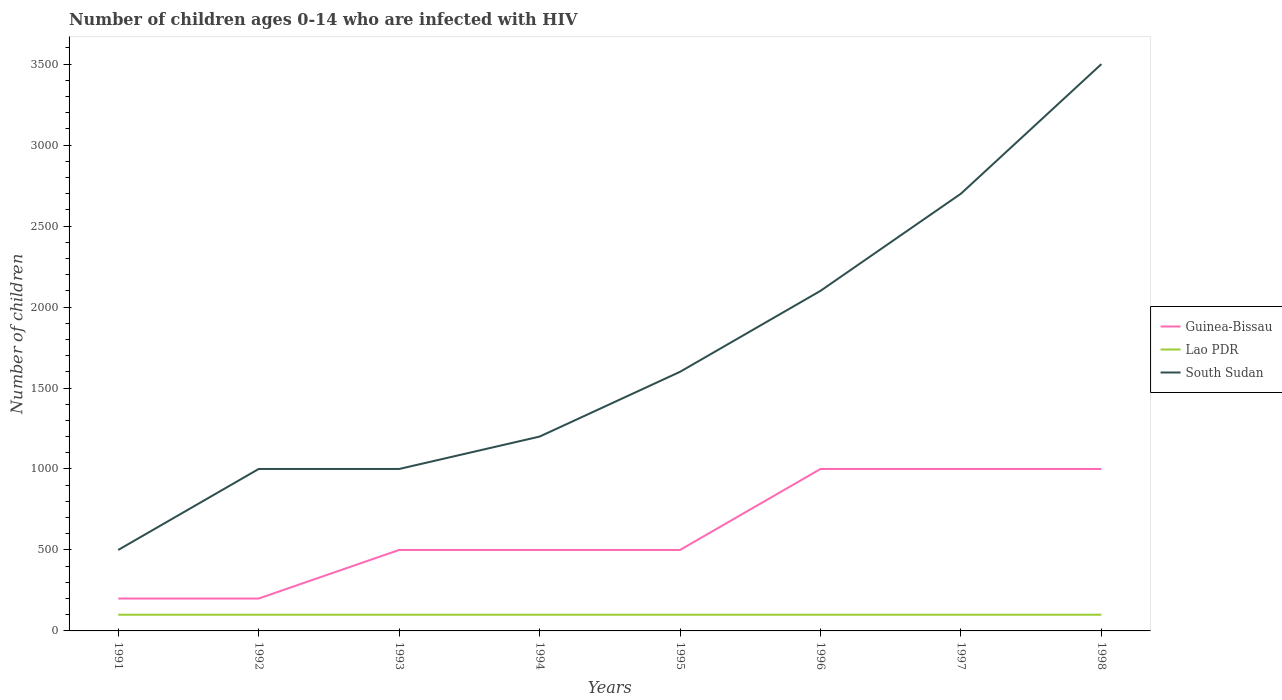How many different coloured lines are there?
Make the answer very short. 3. Is the number of lines equal to the number of legend labels?
Keep it short and to the point. Yes. Across all years, what is the maximum number of HIV infected children in Lao PDR?
Ensure brevity in your answer.  100. What is the difference between the highest and the second highest number of HIV infected children in Lao PDR?
Give a very brief answer. 0. Is the number of HIV infected children in Guinea-Bissau strictly greater than the number of HIV infected children in South Sudan over the years?
Your answer should be compact. Yes. How many years are there in the graph?
Give a very brief answer. 8. What is the difference between two consecutive major ticks on the Y-axis?
Give a very brief answer. 500. Does the graph contain any zero values?
Your answer should be very brief. No. Does the graph contain grids?
Your answer should be very brief. No. Where does the legend appear in the graph?
Keep it short and to the point. Center right. What is the title of the graph?
Your response must be concise. Number of children ages 0-14 who are infected with HIV. Does "Guinea-Bissau" appear as one of the legend labels in the graph?
Ensure brevity in your answer.  Yes. What is the label or title of the Y-axis?
Ensure brevity in your answer.  Number of children. What is the Number of children in Lao PDR in 1991?
Make the answer very short. 100. What is the Number of children of South Sudan in 1991?
Keep it short and to the point. 500. What is the Number of children of Guinea-Bissau in 1992?
Your answer should be very brief. 200. What is the Number of children in Lao PDR in 1992?
Your response must be concise. 100. What is the Number of children of South Sudan in 1992?
Offer a terse response. 1000. What is the Number of children of Lao PDR in 1993?
Offer a very short reply. 100. What is the Number of children in Guinea-Bissau in 1994?
Offer a terse response. 500. What is the Number of children of South Sudan in 1994?
Your response must be concise. 1200. What is the Number of children of South Sudan in 1995?
Provide a short and direct response. 1600. What is the Number of children in Guinea-Bissau in 1996?
Provide a succinct answer. 1000. What is the Number of children in Lao PDR in 1996?
Give a very brief answer. 100. What is the Number of children in South Sudan in 1996?
Your response must be concise. 2100. What is the Number of children in Guinea-Bissau in 1997?
Give a very brief answer. 1000. What is the Number of children of South Sudan in 1997?
Your answer should be very brief. 2700. What is the Number of children of South Sudan in 1998?
Your answer should be compact. 3500. Across all years, what is the maximum Number of children in Guinea-Bissau?
Your answer should be very brief. 1000. Across all years, what is the maximum Number of children in South Sudan?
Your answer should be compact. 3500. Across all years, what is the minimum Number of children in Lao PDR?
Keep it short and to the point. 100. What is the total Number of children in Guinea-Bissau in the graph?
Provide a succinct answer. 4900. What is the total Number of children of Lao PDR in the graph?
Your answer should be compact. 800. What is the total Number of children of South Sudan in the graph?
Give a very brief answer. 1.36e+04. What is the difference between the Number of children of Lao PDR in 1991 and that in 1992?
Your answer should be very brief. 0. What is the difference between the Number of children of South Sudan in 1991 and that in 1992?
Your answer should be compact. -500. What is the difference between the Number of children in Guinea-Bissau in 1991 and that in 1993?
Provide a short and direct response. -300. What is the difference between the Number of children of Lao PDR in 1991 and that in 1993?
Keep it short and to the point. 0. What is the difference between the Number of children of South Sudan in 1991 and that in 1993?
Keep it short and to the point. -500. What is the difference between the Number of children in Guinea-Bissau in 1991 and that in 1994?
Your response must be concise. -300. What is the difference between the Number of children in South Sudan in 1991 and that in 1994?
Give a very brief answer. -700. What is the difference between the Number of children of Guinea-Bissau in 1991 and that in 1995?
Provide a succinct answer. -300. What is the difference between the Number of children in Lao PDR in 1991 and that in 1995?
Give a very brief answer. 0. What is the difference between the Number of children in South Sudan in 1991 and that in 1995?
Your answer should be compact. -1100. What is the difference between the Number of children of Guinea-Bissau in 1991 and that in 1996?
Ensure brevity in your answer.  -800. What is the difference between the Number of children of South Sudan in 1991 and that in 1996?
Your response must be concise. -1600. What is the difference between the Number of children of Guinea-Bissau in 1991 and that in 1997?
Give a very brief answer. -800. What is the difference between the Number of children of Lao PDR in 1991 and that in 1997?
Keep it short and to the point. 0. What is the difference between the Number of children in South Sudan in 1991 and that in 1997?
Offer a very short reply. -2200. What is the difference between the Number of children of Guinea-Bissau in 1991 and that in 1998?
Your answer should be very brief. -800. What is the difference between the Number of children of Lao PDR in 1991 and that in 1998?
Keep it short and to the point. 0. What is the difference between the Number of children in South Sudan in 1991 and that in 1998?
Provide a succinct answer. -3000. What is the difference between the Number of children of Guinea-Bissau in 1992 and that in 1993?
Your answer should be compact. -300. What is the difference between the Number of children of Guinea-Bissau in 1992 and that in 1994?
Your answer should be very brief. -300. What is the difference between the Number of children of South Sudan in 1992 and that in 1994?
Your answer should be very brief. -200. What is the difference between the Number of children in Guinea-Bissau in 1992 and that in 1995?
Your answer should be compact. -300. What is the difference between the Number of children in South Sudan in 1992 and that in 1995?
Provide a short and direct response. -600. What is the difference between the Number of children in Guinea-Bissau in 1992 and that in 1996?
Your response must be concise. -800. What is the difference between the Number of children of Lao PDR in 1992 and that in 1996?
Offer a very short reply. 0. What is the difference between the Number of children of South Sudan in 1992 and that in 1996?
Keep it short and to the point. -1100. What is the difference between the Number of children in Guinea-Bissau in 1992 and that in 1997?
Offer a very short reply. -800. What is the difference between the Number of children of South Sudan in 1992 and that in 1997?
Offer a terse response. -1700. What is the difference between the Number of children of Guinea-Bissau in 1992 and that in 1998?
Give a very brief answer. -800. What is the difference between the Number of children of South Sudan in 1992 and that in 1998?
Ensure brevity in your answer.  -2500. What is the difference between the Number of children of Guinea-Bissau in 1993 and that in 1994?
Give a very brief answer. 0. What is the difference between the Number of children of Lao PDR in 1993 and that in 1994?
Offer a very short reply. 0. What is the difference between the Number of children in South Sudan in 1993 and that in 1994?
Your answer should be compact. -200. What is the difference between the Number of children of South Sudan in 1993 and that in 1995?
Your answer should be compact. -600. What is the difference between the Number of children of Guinea-Bissau in 1993 and that in 1996?
Keep it short and to the point. -500. What is the difference between the Number of children of South Sudan in 1993 and that in 1996?
Your answer should be compact. -1100. What is the difference between the Number of children in Guinea-Bissau in 1993 and that in 1997?
Give a very brief answer. -500. What is the difference between the Number of children in South Sudan in 1993 and that in 1997?
Offer a very short reply. -1700. What is the difference between the Number of children in Guinea-Bissau in 1993 and that in 1998?
Keep it short and to the point. -500. What is the difference between the Number of children of South Sudan in 1993 and that in 1998?
Offer a terse response. -2500. What is the difference between the Number of children in Lao PDR in 1994 and that in 1995?
Keep it short and to the point. 0. What is the difference between the Number of children of South Sudan in 1994 and that in 1995?
Provide a short and direct response. -400. What is the difference between the Number of children in Guinea-Bissau in 1994 and that in 1996?
Offer a terse response. -500. What is the difference between the Number of children of Lao PDR in 1994 and that in 1996?
Your response must be concise. 0. What is the difference between the Number of children in South Sudan in 1994 and that in 1996?
Provide a succinct answer. -900. What is the difference between the Number of children of Guinea-Bissau in 1994 and that in 1997?
Ensure brevity in your answer.  -500. What is the difference between the Number of children of South Sudan in 1994 and that in 1997?
Your response must be concise. -1500. What is the difference between the Number of children of Guinea-Bissau in 1994 and that in 1998?
Your response must be concise. -500. What is the difference between the Number of children in South Sudan in 1994 and that in 1998?
Keep it short and to the point. -2300. What is the difference between the Number of children of Guinea-Bissau in 1995 and that in 1996?
Offer a terse response. -500. What is the difference between the Number of children in Lao PDR in 1995 and that in 1996?
Your response must be concise. 0. What is the difference between the Number of children of South Sudan in 1995 and that in 1996?
Provide a succinct answer. -500. What is the difference between the Number of children in Guinea-Bissau in 1995 and that in 1997?
Give a very brief answer. -500. What is the difference between the Number of children in South Sudan in 1995 and that in 1997?
Your response must be concise. -1100. What is the difference between the Number of children of Guinea-Bissau in 1995 and that in 1998?
Offer a very short reply. -500. What is the difference between the Number of children of Lao PDR in 1995 and that in 1998?
Provide a succinct answer. 0. What is the difference between the Number of children of South Sudan in 1995 and that in 1998?
Provide a succinct answer. -1900. What is the difference between the Number of children of Guinea-Bissau in 1996 and that in 1997?
Make the answer very short. 0. What is the difference between the Number of children of Lao PDR in 1996 and that in 1997?
Give a very brief answer. 0. What is the difference between the Number of children of South Sudan in 1996 and that in 1997?
Your answer should be compact. -600. What is the difference between the Number of children of South Sudan in 1996 and that in 1998?
Provide a succinct answer. -1400. What is the difference between the Number of children of Guinea-Bissau in 1997 and that in 1998?
Give a very brief answer. 0. What is the difference between the Number of children of South Sudan in 1997 and that in 1998?
Ensure brevity in your answer.  -800. What is the difference between the Number of children of Guinea-Bissau in 1991 and the Number of children of South Sudan in 1992?
Give a very brief answer. -800. What is the difference between the Number of children in Lao PDR in 1991 and the Number of children in South Sudan in 1992?
Your response must be concise. -900. What is the difference between the Number of children of Guinea-Bissau in 1991 and the Number of children of South Sudan in 1993?
Keep it short and to the point. -800. What is the difference between the Number of children of Lao PDR in 1991 and the Number of children of South Sudan in 1993?
Ensure brevity in your answer.  -900. What is the difference between the Number of children in Guinea-Bissau in 1991 and the Number of children in Lao PDR in 1994?
Your answer should be compact. 100. What is the difference between the Number of children in Guinea-Bissau in 1991 and the Number of children in South Sudan in 1994?
Give a very brief answer. -1000. What is the difference between the Number of children in Lao PDR in 1991 and the Number of children in South Sudan in 1994?
Ensure brevity in your answer.  -1100. What is the difference between the Number of children in Guinea-Bissau in 1991 and the Number of children in South Sudan in 1995?
Give a very brief answer. -1400. What is the difference between the Number of children in Lao PDR in 1991 and the Number of children in South Sudan in 1995?
Ensure brevity in your answer.  -1500. What is the difference between the Number of children in Guinea-Bissau in 1991 and the Number of children in South Sudan in 1996?
Provide a short and direct response. -1900. What is the difference between the Number of children of Lao PDR in 1991 and the Number of children of South Sudan in 1996?
Keep it short and to the point. -2000. What is the difference between the Number of children of Guinea-Bissau in 1991 and the Number of children of Lao PDR in 1997?
Make the answer very short. 100. What is the difference between the Number of children of Guinea-Bissau in 1991 and the Number of children of South Sudan in 1997?
Make the answer very short. -2500. What is the difference between the Number of children of Lao PDR in 1991 and the Number of children of South Sudan in 1997?
Make the answer very short. -2600. What is the difference between the Number of children in Guinea-Bissau in 1991 and the Number of children in South Sudan in 1998?
Your answer should be compact. -3300. What is the difference between the Number of children of Lao PDR in 1991 and the Number of children of South Sudan in 1998?
Keep it short and to the point. -3400. What is the difference between the Number of children in Guinea-Bissau in 1992 and the Number of children in South Sudan in 1993?
Keep it short and to the point. -800. What is the difference between the Number of children in Lao PDR in 1992 and the Number of children in South Sudan in 1993?
Your response must be concise. -900. What is the difference between the Number of children of Guinea-Bissau in 1992 and the Number of children of Lao PDR in 1994?
Provide a short and direct response. 100. What is the difference between the Number of children of Guinea-Bissau in 1992 and the Number of children of South Sudan in 1994?
Your response must be concise. -1000. What is the difference between the Number of children in Lao PDR in 1992 and the Number of children in South Sudan in 1994?
Your answer should be compact. -1100. What is the difference between the Number of children of Guinea-Bissau in 1992 and the Number of children of Lao PDR in 1995?
Provide a short and direct response. 100. What is the difference between the Number of children in Guinea-Bissau in 1992 and the Number of children in South Sudan in 1995?
Your answer should be compact. -1400. What is the difference between the Number of children in Lao PDR in 1992 and the Number of children in South Sudan in 1995?
Provide a short and direct response. -1500. What is the difference between the Number of children in Guinea-Bissau in 1992 and the Number of children in South Sudan in 1996?
Give a very brief answer. -1900. What is the difference between the Number of children of Lao PDR in 1992 and the Number of children of South Sudan in 1996?
Your response must be concise. -2000. What is the difference between the Number of children of Guinea-Bissau in 1992 and the Number of children of South Sudan in 1997?
Offer a terse response. -2500. What is the difference between the Number of children in Lao PDR in 1992 and the Number of children in South Sudan in 1997?
Your answer should be very brief. -2600. What is the difference between the Number of children of Guinea-Bissau in 1992 and the Number of children of South Sudan in 1998?
Your answer should be very brief. -3300. What is the difference between the Number of children in Lao PDR in 1992 and the Number of children in South Sudan in 1998?
Your answer should be very brief. -3400. What is the difference between the Number of children of Guinea-Bissau in 1993 and the Number of children of Lao PDR in 1994?
Provide a succinct answer. 400. What is the difference between the Number of children in Guinea-Bissau in 1993 and the Number of children in South Sudan in 1994?
Keep it short and to the point. -700. What is the difference between the Number of children of Lao PDR in 1993 and the Number of children of South Sudan in 1994?
Offer a terse response. -1100. What is the difference between the Number of children in Guinea-Bissau in 1993 and the Number of children in South Sudan in 1995?
Make the answer very short. -1100. What is the difference between the Number of children of Lao PDR in 1993 and the Number of children of South Sudan in 1995?
Keep it short and to the point. -1500. What is the difference between the Number of children of Guinea-Bissau in 1993 and the Number of children of Lao PDR in 1996?
Your response must be concise. 400. What is the difference between the Number of children in Guinea-Bissau in 1993 and the Number of children in South Sudan in 1996?
Offer a terse response. -1600. What is the difference between the Number of children of Lao PDR in 1993 and the Number of children of South Sudan in 1996?
Keep it short and to the point. -2000. What is the difference between the Number of children of Guinea-Bissau in 1993 and the Number of children of Lao PDR in 1997?
Your response must be concise. 400. What is the difference between the Number of children of Guinea-Bissau in 1993 and the Number of children of South Sudan in 1997?
Provide a succinct answer. -2200. What is the difference between the Number of children of Lao PDR in 1993 and the Number of children of South Sudan in 1997?
Your answer should be very brief. -2600. What is the difference between the Number of children in Guinea-Bissau in 1993 and the Number of children in South Sudan in 1998?
Ensure brevity in your answer.  -3000. What is the difference between the Number of children in Lao PDR in 1993 and the Number of children in South Sudan in 1998?
Keep it short and to the point. -3400. What is the difference between the Number of children of Guinea-Bissau in 1994 and the Number of children of South Sudan in 1995?
Your answer should be very brief. -1100. What is the difference between the Number of children in Lao PDR in 1994 and the Number of children in South Sudan in 1995?
Your answer should be very brief. -1500. What is the difference between the Number of children of Guinea-Bissau in 1994 and the Number of children of South Sudan in 1996?
Provide a short and direct response. -1600. What is the difference between the Number of children in Lao PDR in 1994 and the Number of children in South Sudan in 1996?
Your answer should be compact. -2000. What is the difference between the Number of children in Guinea-Bissau in 1994 and the Number of children in Lao PDR in 1997?
Your answer should be compact. 400. What is the difference between the Number of children of Guinea-Bissau in 1994 and the Number of children of South Sudan in 1997?
Provide a short and direct response. -2200. What is the difference between the Number of children in Lao PDR in 1994 and the Number of children in South Sudan in 1997?
Your response must be concise. -2600. What is the difference between the Number of children in Guinea-Bissau in 1994 and the Number of children in Lao PDR in 1998?
Your answer should be compact. 400. What is the difference between the Number of children in Guinea-Bissau in 1994 and the Number of children in South Sudan in 1998?
Ensure brevity in your answer.  -3000. What is the difference between the Number of children of Lao PDR in 1994 and the Number of children of South Sudan in 1998?
Offer a very short reply. -3400. What is the difference between the Number of children in Guinea-Bissau in 1995 and the Number of children in South Sudan in 1996?
Your response must be concise. -1600. What is the difference between the Number of children in Lao PDR in 1995 and the Number of children in South Sudan in 1996?
Give a very brief answer. -2000. What is the difference between the Number of children in Guinea-Bissau in 1995 and the Number of children in South Sudan in 1997?
Your response must be concise. -2200. What is the difference between the Number of children in Lao PDR in 1995 and the Number of children in South Sudan in 1997?
Your answer should be compact. -2600. What is the difference between the Number of children in Guinea-Bissau in 1995 and the Number of children in Lao PDR in 1998?
Provide a succinct answer. 400. What is the difference between the Number of children of Guinea-Bissau in 1995 and the Number of children of South Sudan in 1998?
Your answer should be very brief. -3000. What is the difference between the Number of children of Lao PDR in 1995 and the Number of children of South Sudan in 1998?
Offer a very short reply. -3400. What is the difference between the Number of children in Guinea-Bissau in 1996 and the Number of children in Lao PDR in 1997?
Offer a terse response. 900. What is the difference between the Number of children in Guinea-Bissau in 1996 and the Number of children in South Sudan in 1997?
Make the answer very short. -1700. What is the difference between the Number of children in Lao PDR in 1996 and the Number of children in South Sudan in 1997?
Your answer should be compact. -2600. What is the difference between the Number of children in Guinea-Bissau in 1996 and the Number of children in Lao PDR in 1998?
Provide a succinct answer. 900. What is the difference between the Number of children of Guinea-Bissau in 1996 and the Number of children of South Sudan in 1998?
Provide a short and direct response. -2500. What is the difference between the Number of children in Lao PDR in 1996 and the Number of children in South Sudan in 1998?
Offer a very short reply. -3400. What is the difference between the Number of children in Guinea-Bissau in 1997 and the Number of children in Lao PDR in 1998?
Provide a short and direct response. 900. What is the difference between the Number of children of Guinea-Bissau in 1997 and the Number of children of South Sudan in 1998?
Your answer should be very brief. -2500. What is the difference between the Number of children of Lao PDR in 1997 and the Number of children of South Sudan in 1998?
Your answer should be very brief. -3400. What is the average Number of children in Guinea-Bissau per year?
Provide a succinct answer. 612.5. What is the average Number of children of South Sudan per year?
Your response must be concise. 1700. In the year 1991, what is the difference between the Number of children of Guinea-Bissau and Number of children of Lao PDR?
Your response must be concise. 100. In the year 1991, what is the difference between the Number of children of Guinea-Bissau and Number of children of South Sudan?
Make the answer very short. -300. In the year 1991, what is the difference between the Number of children in Lao PDR and Number of children in South Sudan?
Give a very brief answer. -400. In the year 1992, what is the difference between the Number of children of Guinea-Bissau and Number of children of Lao PDR?
Offer a very short reply. 100. In the year 1992, what is the difference between the Number of children in Guinea-Bissau and Number of children in South Sudan?
Make the answer very short. -800. In the year 1992, what is the difference between the Number of children in Lao PDR and Number of children in South Sudan?
Give a very brief answer. -900. In the year 1993, what is the difference between the Number of children of Guinea-Bissau and Number of children of Lao PDR?
Your answer should be very brief. 400. In the year 1993, what is the difference between the Number of children in Guinea-Bissau and Number of children in South Sudan?
Provide a short and direct response. -500. In the year 1993, what is the difference between the Number of children in Lao PDR and Number of children in South Sudan?
Provide a short and direct response. -900. In the year 1994, what is the difference between the Number of children in Guinea-Bissau and Number of children in Lao PDR?
Make the answer very short. 400. In the year 1994, what is the difference between the Number of children of Guinea-Bissau and Number of children of South Sudan?
Your answer should be very brief. -700. In the year 1994, what is the difference between the Number of children of Lao PDR and Number of children of South Sudan?
Your answer should be compact. -1100. In the year 1995, what is the difference between the Number of children in Guinea-Bissau and Number of children in Lao PDR?
Offer a terse response. 400. In the year 1995, what is the difference between the Number of children of Guinea-Bissau and Number of children of South Sudan?
Offer a very short reply. -1100. In the year 1995, what is the difference between the Number of children of Lao PDR and Number of children of South Sudan?
Your answer should be very brief. -1500. In the year 1996, what is the difference between the Number of children in Guinea-Bissau and Number of children in Lao PDR?
Your response must be concise. 900. In the year 1996, what is the difference between the Number of children of Guinea-Bissau and Number of children of South Sudan?
Your answer should be very brief. -1100. In the year 1996, what is the difference between the Number of children in Lao PDR and Number of children in South Sudan?
Ensure brevity in your answer.  -2000. In the year 1997, what is the difference between the Number of children in Guinea-Bissau and Number of children in Lao PDR?
Your answer should be very brief. 900. In the year 1997, what is the difference between the Number of children in Guinea-Bissau and Number of children in South Sudan?
Your answer should be compact. -1700. In the year 1997, what is the difference between the Number of children in Lao PDR and Number of children in South Sudan?
Your answer should be very brief. -2600. In the year 1998, what is the difference between the Number of children of Guinea-Bissau and Number of children of Lao PDR?
Give a very brief answer. 900. In the year 1998, what is the difference between the Number of children of Guinea-Bissau and Number of children of South Sudan?
Offer a very short reply. -2500. In the year 1998, what is the difference between the Number of children in Lao PDR and Number of children in South Sudan?
Your response must be concise. -3400. What is the ratio of the Number of children in Lao PDR in 1991 to that in 1992?
Ensure brevity in your answer.  1. What is the ratio of the Number of children of South Sudan in 1991 to that in 1992?
Keep it short and to the point. 0.5. What is the ratio of the Number of children of South Sudan in 1991 to that in 1993?
Your answer should be compact. 0.5. What is the ratio of the Number of children of Lao PDR in 1991 to that in 1994?
Make the answer very short. 1. What is the ratio of the Number of children in South Sudan in 1991 to that in 1994?
Your answer should be very brief. 0.42. What is the ratio of the Number of children of Guinea-Bissau in 1991 to that in 1995?
Provide a short and direct response. 0.4. What is the ratio of the Number of children in South Sudan in 1991 to that in 1995?
Offer a terse response. 0.31. What is the ratio of the Number of children of Guinea-Bissau in 1991 to that in 1996?
Ensure brevity in your answer.  0.2. What is the ratio of the Number of children of South Sudan in 1991 to that in 1996?
Give a very brief answer. 0.24. What is the ratio of the Number of children in Guinea-Bissau in 1991 to that in 1997?
Give a very brief answer. 0.2. What is the ratio of the Number of children of Lao PDR in 1991 to that in 1997?
Your answer should be compact. 1. What is the ratio of the Number of children in South Sudan in 1991 to that in 1997?
Offer a terse response. 0.19. What is the ratio of the Number of children of South Sudan in 1991 to that in 1998?
Make the answer very short. 0.14. What is the ratio of the Number of children of Guinea-Bissau in 1992 to that in 1993?
Provide a short and direct response. 0.4. What is the ratio of the Number of children in Lao PDR in 1992 to that in 1994?
Offer a terse response. 1. What is the ratio of the Number of children of South Sudan in 1992 to that in 1994?
Your response must be concise. 0.83. What is the ratio of the Number of children of Guinea-Bissau in 1992 to that in 1995?
Keep it short and to the point. 0.4. What is the ratio of the Number of children in Lao PDR in 1992 to that in 1995?
Give a very brief answer. 1. What is the ratio of the Number of children in Guinea-Bissau in 1992 to that in 1996?
Provide a short and direct response. 0.2. What is the ratio of the Number of children of Lao PDR in 1992 to that in 1996?
Make the answer very short. 1. What is the ratio of the Number of children of South Sudan in 1992 to that in 1996?
Give a very brief answer. 0.48. What is the ratio of the Number of children of Guinea-Bissau in 1992 to that in 1997?
Provide a short and direct response. 0.2. What is the ratio of the Number of children in Lao PDR in 1992 to that in 1997?
Your response must be concise. 1. What is the ratio of the Number of children of South Sudan in 1992 to that in 1997?
Your response must be concise. 0.37. What is the ratio of the Number of children in Lao PDR in 1992 to that in 1998?
Your answer should be compact. 1. What is the ratio of the Number of children of South Sudan in 1992 to that in 1998?
Your response must be concise. 0.29. What is the ratio of the Number of children of Guinea-Bissau in 1993 to that in 1994?
Provide a succinct answer. 1. What is the ratio of the Number of children of Lao PDR in 1993 to that in 1994?
Offer a terse response. 1. What is the ratio of the Number of children of South Sudan in 1993 to that in 1994?
Make the answer very short. 0.83. What is the ratio of the Number of children of Lao PDR in 1993 to that in 1995?
Your answer should be very brief. 1. What is the ratio of the Number of children in South Sudan in 1993 to that in 1995?
Your answer should be very brief. 0.62. What is the ratio of the Number of children in Lao PDR in 1993 to that in 1996?
Your answer should be very brief. 1. What is the ratio of the Number of children in South Sudan in 1993 to that in 1996?
Give a very brief answer. 0.48. What is the ratio of the Number of children in Guinea-Bissau in 1993 to that in 1997?
Offer a terse response. 0.5. What is the ratio of the Number of children in South Sudan in 1993 to that in 1997?
Make the answer very short. 0.37. What is the ratio of the Number of children in Guinea-Bissau in 1993 to that in 1998?
Give a very brief answer. 0.5. What is the ratio of the Number of children of South Sudan in 1993 to that in 1998?
Give a very brief answer. 0.29. What is the ratio of the Number of children of Guinea-Bissau in 1994 to that in 1995?
Provide a succinct answer. 1. What is the ratio of the Number of children in South Sudan in 1994 to that in 1996?
Offer a terse response. 0.57. What is the ratio of the Number of children of South Sudan in 1994 to that in 1997?
Make the answer very short. 0.44. What is the ratio of the Number of children in Guinea-Bissau in 1994 to that in 1998?
Make the answer very short. 0.5. What is the ratio of the Number of children of Lao PDR in 1994 to that in 1998?
Offer a terse response. 1. What is the ratio of the Number of children in South Sudan in 1994 to that in 1998?
Ensure brevity in your answer.  0.34. What is the ratio of the Number of children in Lao PDR in 1995 to that in 1996?
Provide a short and direct response. 1. What is the ratio of the Number of children of South Sudan in 1995 to that in 1996?
Offer a very short reply. 0.76. What is the ratio of the Number of children of Guinea-Bissau in 1995 to that in 1997?
Offer a very short reply. 0.5. What is the ratio of the Number of children in Lao PDR in 1995 to that in 1997?
Give a very brief answer. 1. What is the ratio of the Number of children of South Sudan in 1995 to that in 1997?
Offer a terse response. 0.59. What is the ratio of the Number of children of Lao PDR in 1995 to that in 1998?
Give a very brief answer. 1. What is the ratio of the Number of children in South Sudan in 1995 to that in 1998?
Offer a terse response. 0.46. What is the ratio of the Number of children in Lao PDR in 1996 to that in 1997?
Provide a short and direct response. 1. What is the ratio of the Number of children in Lao PDR in 1996 to that in 1998?
Ensure brevity in your answer.  1. What is the ratio of the Number of children of Guinea-Bissau in 1997 to that in 1998?
Keep it short and to the point. 1. What is the ratio of the Number of children of South Sudan in 1997 to that in 1998?
Offer a very short reply. 0.77. What is the difference between the highest and the second highest Number of children in Guinea-Bissau?
Your answer should be very brief. 0. What is the difference between the highest and the second highest Number of children in Lao PDR?
Ensure brevity in your answer.  0. What is the difference between the highest and the second highest Number of children in South Sudan?
Offer a terse response. 800. What is the difference between the highest and the lowest Number of children of Guinea-Bissau?
Keep it short and to the point. 800. What is the difference between the highest and the lowest Number of children in South Sudan?
Your answer should be very brief. 3000. 